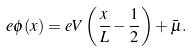<formula> <loc_0><loc_0><loc_500><loc_500>e \phi ( x ) = e V \left ( \frac { x } { L } - \frac { 1 } { 2 } \right ) + \bar { \mu } .</formula> 